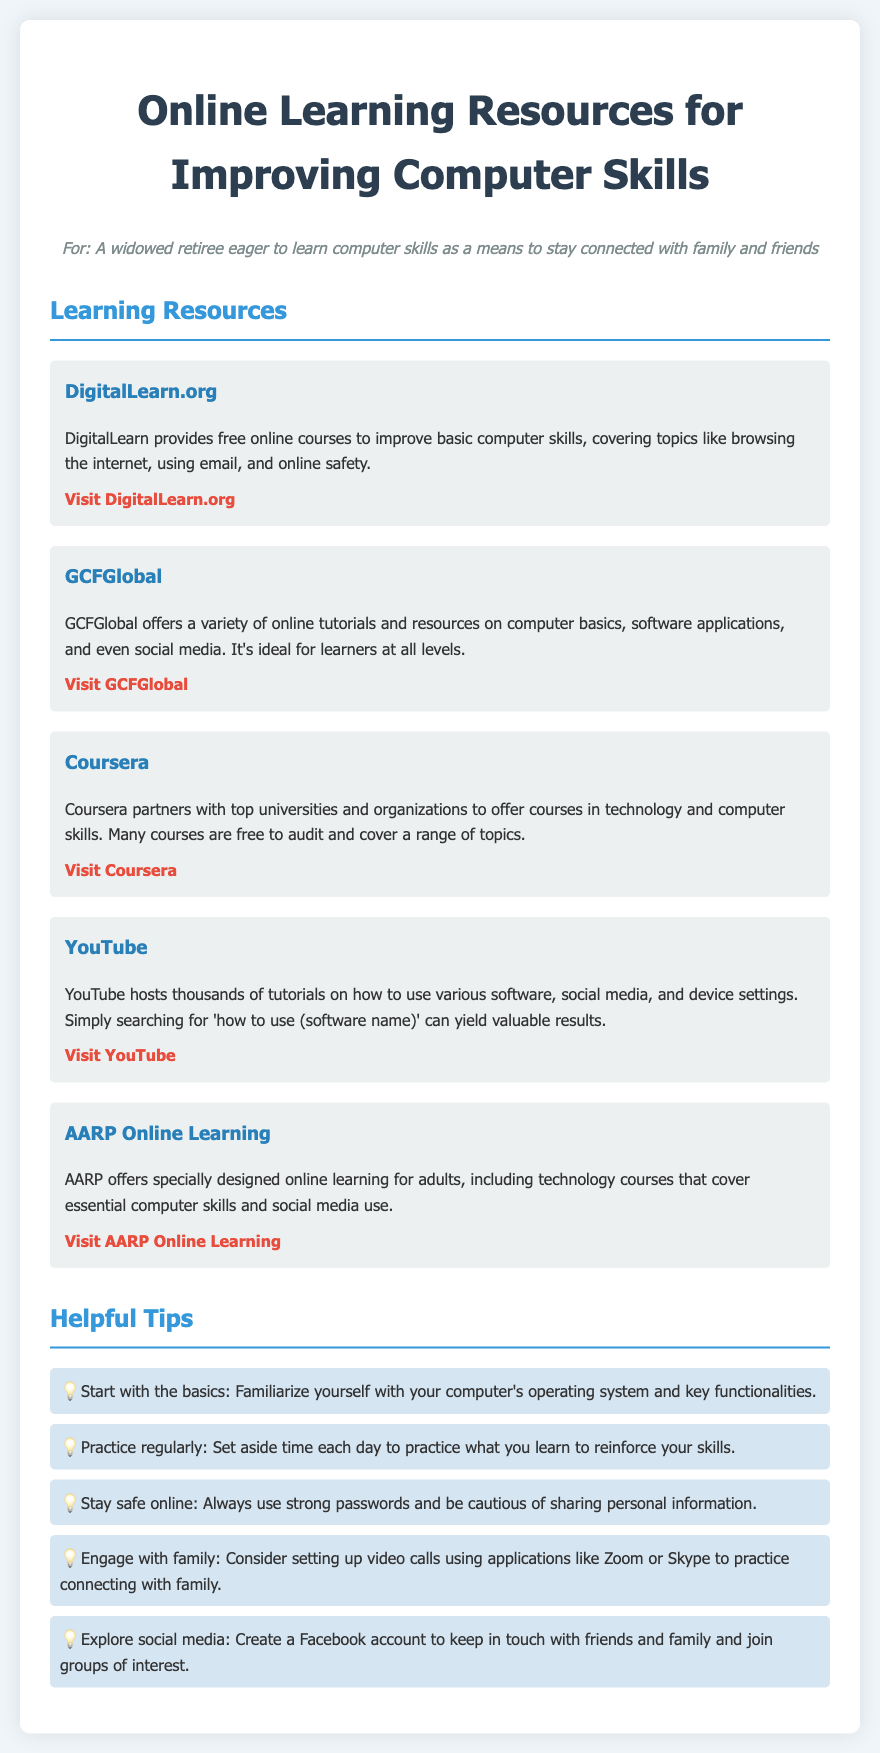What is the name of the website that provides free online courses for basic computer skills? The document lists DigitalLearn.org as a resource for free online courses to improve basic computer skills.
Answer: DigitalLearn.org How many online resources are listed in the document? The document features five different online learning resources for improving computer skills.
Answer: Five What is the first tip provided in the Helpful Tips section? The first tip advises to start with the basics and familiarize with the computer's operating system and functionalities.
Answer: Start with the basics Which platform allows searching for tutorials on software? The document suggests using YouTube for searching tutorials on how to use various software.
Answer: YouTube What kind of courses does AARP Online Learning offer? AARP Online Learning offers technology courses that cover essential computer skills and social media use.
Answer: Technology courses What action is suggested for engaging with family? The document recommends setting up video calls using applications like Zoom or Skype.
Answer: Video calls 